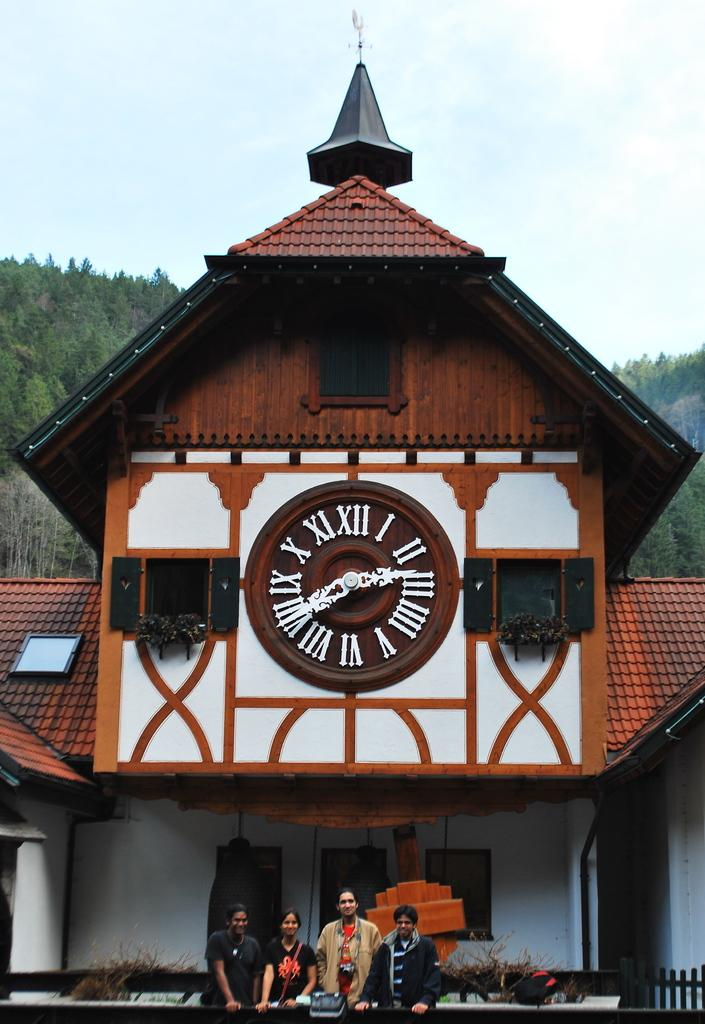<image>
Give a short and clear explanation of the subsequent image. Old building with a clock that shows the hands on the numbers 3 and 8. 